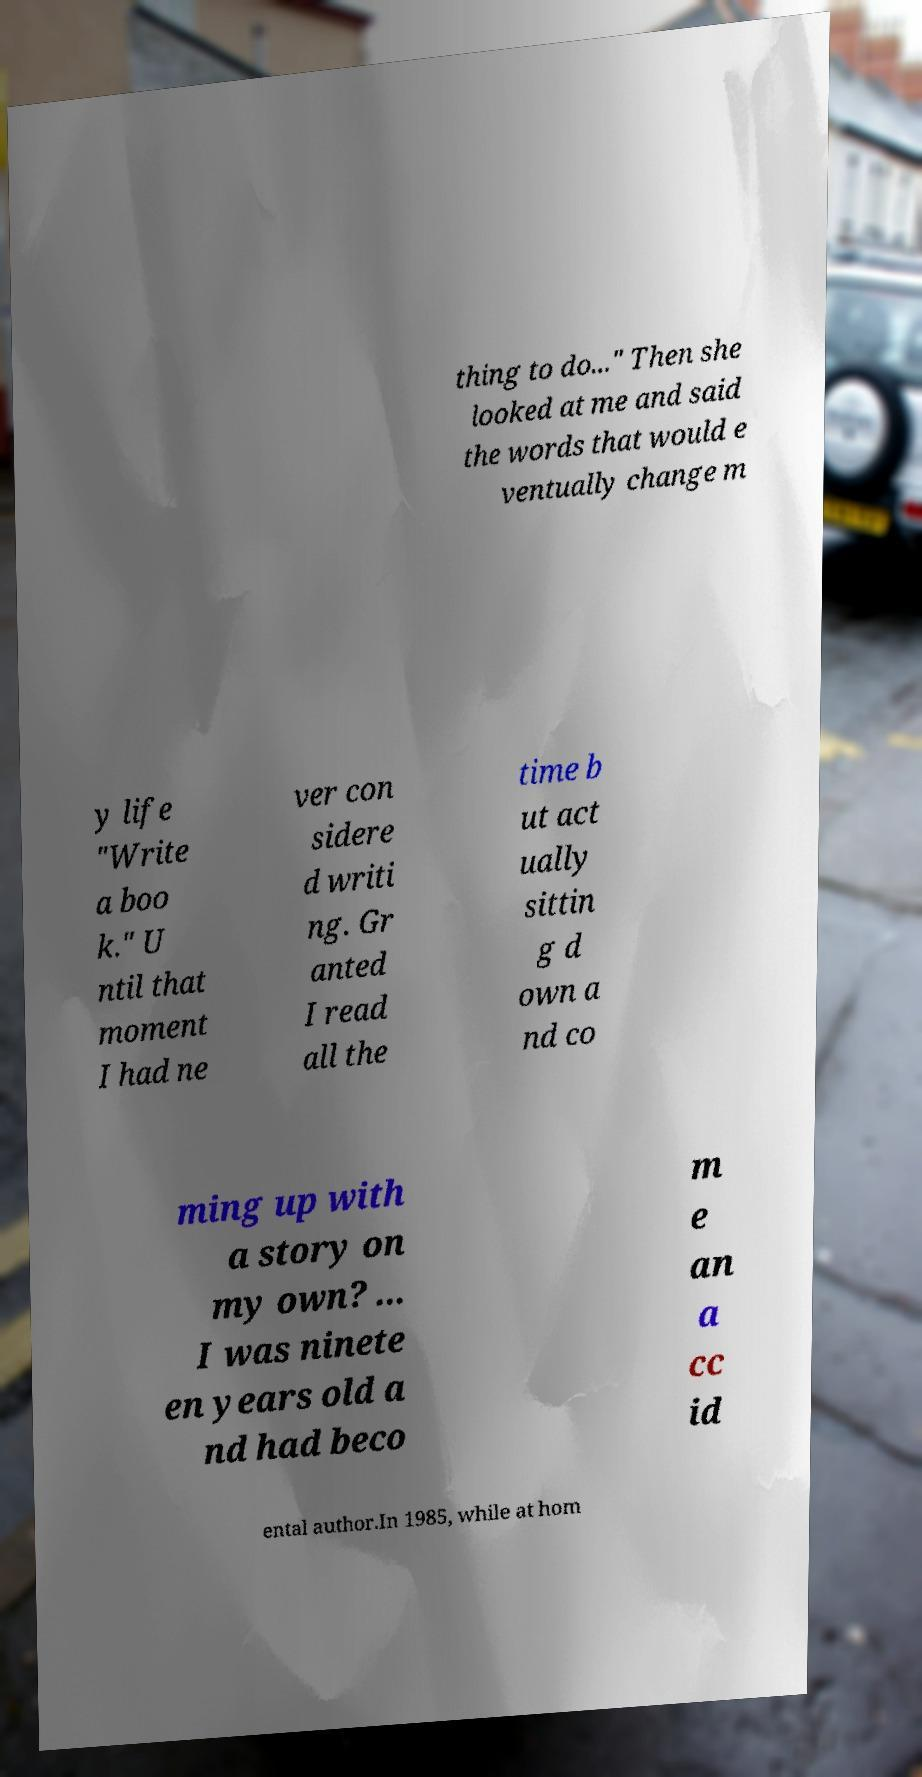Can you accurately transcribe the text from the provided image for me? thing to do..." Then she looked at me and said the words that would e ventually change m y life "Write a boo k." U ntil that moment I had ne ver con sidere d writi ng. Gr anted I read all the time b ut act ually sittin g d own a nd co ming up with a story on my own? ... I was ninete en years old a nd had beco m e an a cc id ental author.In 1985, while at hom 